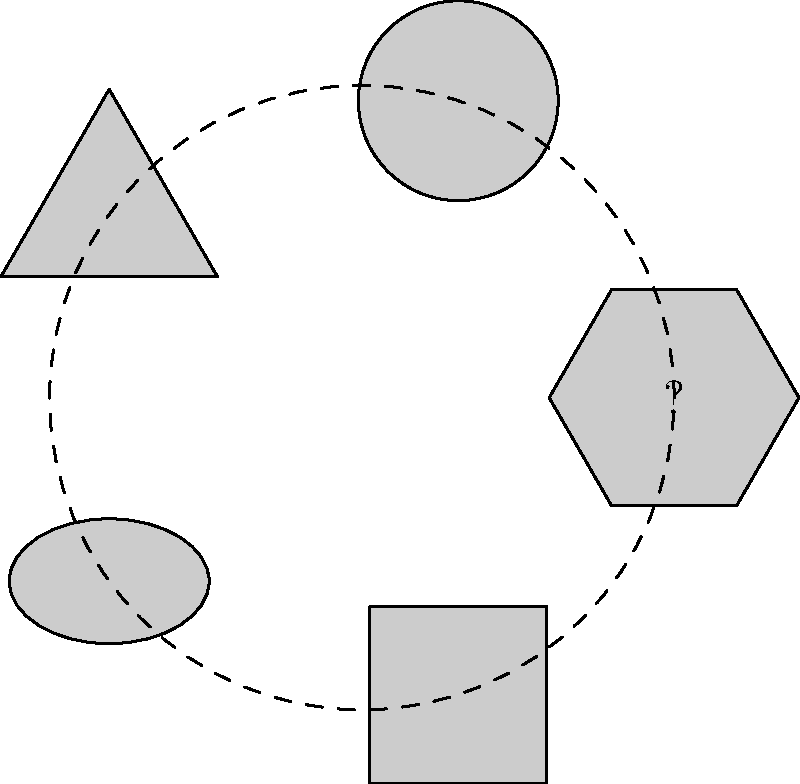In this geometric pattern, five shapes are arranged around a central point. Which shape should logically replace the question mark to complete the sequence? To solve this visual puzzle, we need to analyze the pattern of shapes:

1. Observe that the shapes are arranged in a circular pattern around a central point.
2. The shapes appear in the following order (clockwise from the top):
   - Hexagon
   - Circle
   - Triangle
   - Ellipse
   - Square
3. Notice that the number of sides in each shape follows a pattern:
   - Hexagon: 6 sides
   - Circle: Infinite sides (or 0, depending on interpretation)
   - Triangle: 3 sides
   - Ellipse: Infinite sides (or 0, like the circle)
   - Square: 4 sides
4. The pattern alternates between polygons with decreasing number of sides and curved shapes (circle and ellipse).
5. Following this pattern, the next shape should be a polygon with 5 sides.
6. Therefore, the missing shape that completes the sequence is a pentagon.

This sequence demonstrates a logical progression in the number of sides for polygons (6 → 3 → 4 → 5) interspersed with curved shapes.
Answer: Pentagon 